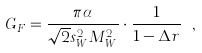<formula> <loc_0><loc_0><loc_500><loc_500>G _ { F } = \frac { \pi \alpha } { \sqrt { 2 } s _ { W } ^ { 2 } M _ { W } ^ { 2 } } \cdot \frac { 1 } { 1 - \Delta r } \ ,</formula> 